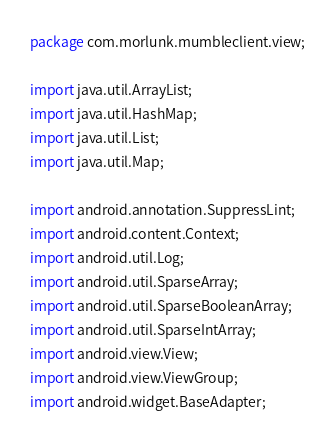Convert code to text. <code><loc_0><loc_0><loc_500><loc_500><_Java_>package com.morlunk.mumbleclient.view;

import java.util.ArrayList;
import java.util.HashMap;
import java.util.List;
import java.util.Map;

import android.annotation.SuppressLint;
import android.content.Context;
import android.util.Log;
import android.util.SparseArray;
import android.util.SparseBooleanArray;
import android.util.SparseIntArray;
import android.view.View;
import android.view.ViewGroup;
import android.widget.BaseAdapter;</code> 